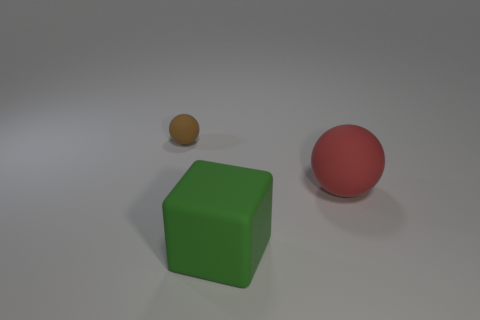What is the color of the other large object that is the same shape as the brown rubber object? red 